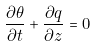Convert formula to latex. <formula><loc_0><loc_0><loc_500><loc_500>\frac { \partial \theta } { \partial t } + \frac { \partial q } { \partial z } = 0</formula> 